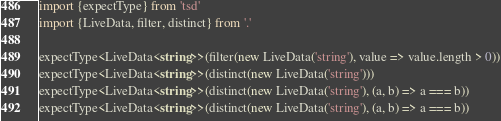<code> <loc_0><loc_0><loc_500><loc_500><_TypeScript_>import {expectType} from 'tsd'
import {LiveData, filter, distinct} from '.'

expectType<LiveData<string>>(filter(new LiveData('string'), value => value.length > 0))
expectType<LiveData<string>>(distinct(new LiveData('string')))
expectType<LiveData<string>>(distinct(new LiveData('string'), (a, b) => a === b))
expectType<LiveData<string>>(distinct(new LiveData('string'), (a, b) => a === b))
</code> 